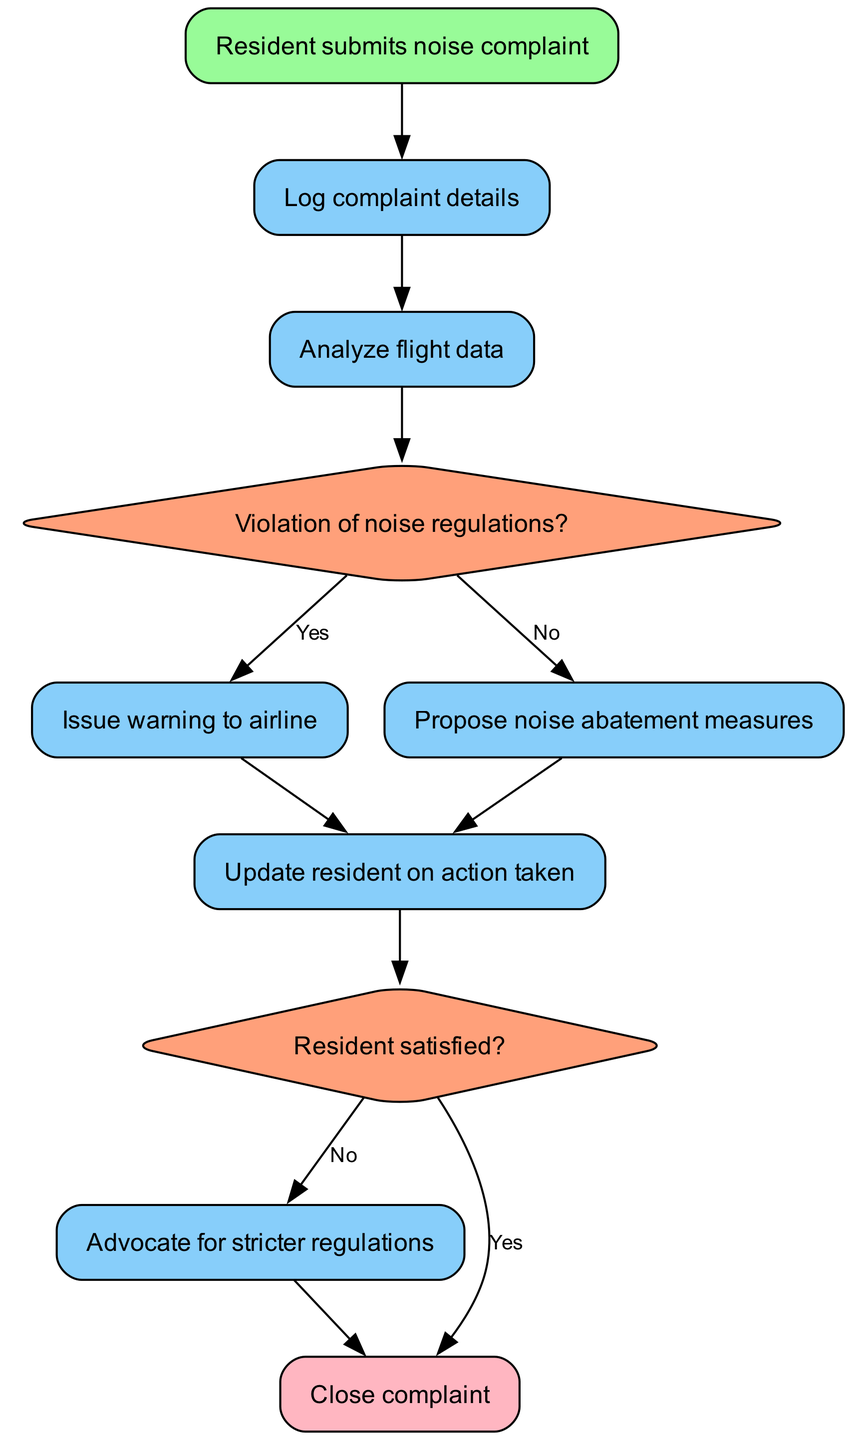What is the first step in the complaint handling process? The first step in the diagram is represented by the "Resident submits noise complaint" node. It indicates the initial action taken by the resident regarding noise issues.
Answer: Resident submits noise complaint How many decision nodes are in the diagram? To find the number of decision nodes, we can count the nodes labeled with 'decision' in the diagram. There are two decision nodes: "Violation of noise regulations?" and "Resident satisfied?".
Answer: 2 What action occurs if there is a violation of noise regulations? In the flowchart, if there is a violation of noise regulations, the process moves to the node labeled "Issue warning to airline" as indicated by the connection from the first decision node.
Answer: Issue warning to airline What happens if the resident is not satisfied with the action taken? If the resident is not satisfied, the diagram shows that the flow proceeds to "Advocate for stricter regulations", reflecting the ongoing efforts to address concerns beyond immediate actions.
Answer: Advocate for stricter regulations What action follows after logging the complaint details? After "Log complaint details", the flowchart indicates that the next action is "Analyze flight data", which is the subsequent step in processing the complaint.
Answer: Analyze flight data How many processes lead to updating the resident on action taken? The counting of processes leading to "Update resident on action taken" includes nodes that process through either "Issue warning to airline" or "Propose noise abatement measures". Both processes lead to this update step, totaling two processes.
Answer: 2 What is the final step in this complaint process? The final node in the diagram is labeled "Close complaint", indicating the end of the complaint handling process after all necessary actions have been taken.
Answer: Close complaint 